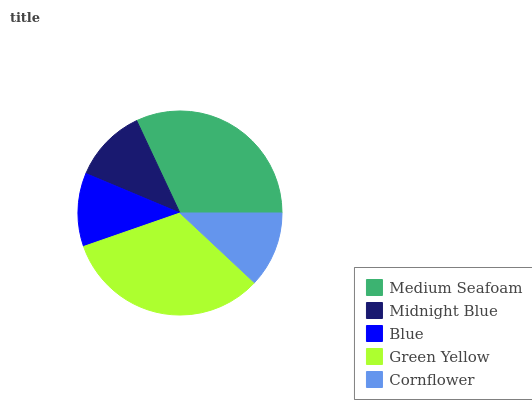Is Blue the minimum?
Answer yes or no. Yes. Is Green Yellow the maximum?
Answer yes or no. Yes. Is Midnight Blue the minimum?
Answer yes or no. No. Is Midnight Blue the maximum?
Answer yes or no. No. Is Medium Seafoam greater than Midnight Blue?
Answer yes or no. Yes. Is Midnight Blue less than Medium Seafoam?
Answer yes or no. Yes. Is Midnight Blue greater than Medium Seafoam?
Answer yes or no. No. Is Medium Seafoam less than Midnight Blue?
Answer yes or no. No. Is Cornflower the high median?
Answer yes or no. Yes. Is Cornflower the low median?
Answer yes or no. Yes. Is Green Yellow the high median?
Answer yes or no. No. Is Midnight Blue the low median?
Answer yes or no. No. 